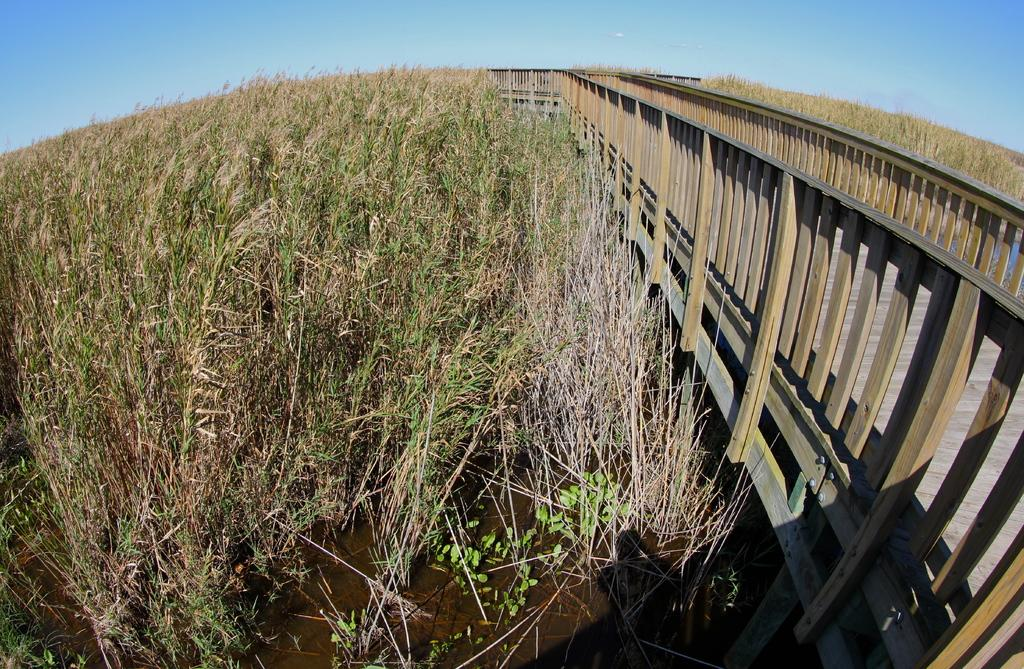What can be seen on the right side of the image? There are planets on the right side of the image. What can be seen on the left side of the image? There are planets on the left side of the image. What structure is located in the middle of the image? There is a bridge in the middle of the image. What is the background of the image? The background of the image appears to be the sky. What type of hair can be seen on the planets in the image? There is no hair present on the planets in the image, as planets are celestial bodies and do not have hair. 